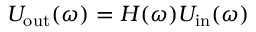Convert formula to latex. <formula><loc_0><loc_0><loc_500><loc_500>U _ { o u t } ( \omega ) = H ( \omega ) U _ { i n } ( \omega )</formula> 